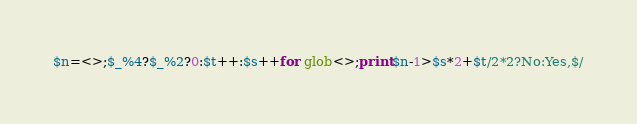Convert code to text. <code><loc_0><loc_0><loc_500><loc_500><_Perl_>$n=<>;$_%4?$_%2?0:$t++:$s++for glob<>;print$n-1>$s*2+$t/2*2?No:Yes,$/</code> 